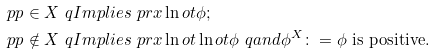<formula> <loc_0><loc_0><loc_500><loc_500>\ p p \in X & \ q I m p l i e s \ p r x \ln o t \phi ; \\ \ p p \notin X & \ q I m p l i e s \ p r x \ln o t \ln o t \phi \ q a n d \phi ^ { X } \colon = \phi \text { is positive} .</formula> 